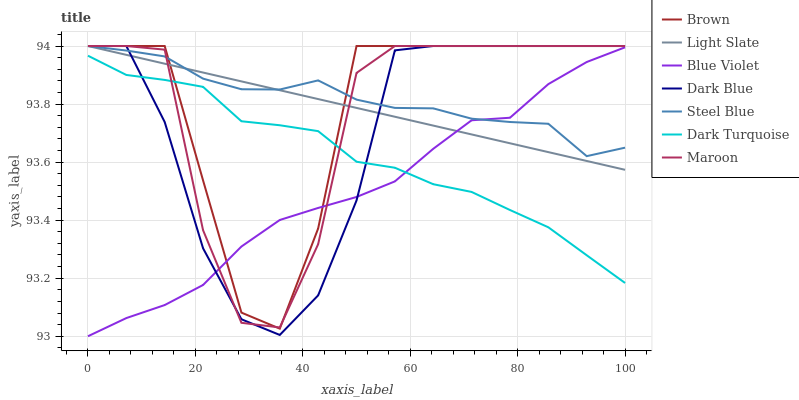Does Blue Violet have the minimum area under the curve?
Answer yes or no. Yes. Does Steel Blue have the maximum area under the curve?
Answer yes or no. Yes. Does Light Slate have the minimum area under the curve?
Answer yes or no. No. Does Light Slate have the maximum area under the curve?
Answer yes or no. No. Is Light Slate the smoothest?
Answer yes or no. Yes. Is Maroon the roughest?
Answer yes or no. Yes. Is Dark Turquoise the smoothest?
Answer yes or no. No. Is Dark Turquoise the roughest?
Answer yes or no. No. Does Blue Violet have the lowest value?
Answer yes or no. Yes. Does Light Slate have the lowest value?
Answer yes or no. No. Does Dark Blue have the highest value?
Answer yes or no. Yes. Does Dark Turquoise have the highest value?
Answer yes or no. No. Is Dark Turquoise less than Steel Blue?
Answer yes or no. Yes. Is Light Slate greater than Dark Turquoise?
Answer yes or no. Yes. Does Light Slate intersect Brown?
Answer yes or no. Yes. Is Light Slate less than Brown?
Answer yes or no. No. Is Light Slate greater than Brown?
Answer yes or no. No. Does Dark Turquoise intersect Steel Blue?
Answer yes or no. No. 